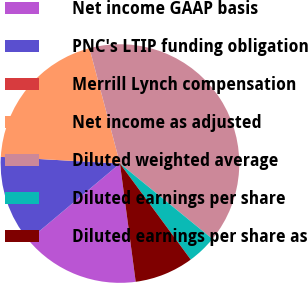Convert chart to OTSL. <chart><loc_0><loc_0><loc_500><loc_500><pie_chart><fcel>Net income GAAP basis<fcel>PNC's LTIP funding obligation<fcel>Merrill Lynch compensation<fcel>Net income as adjusted<fcel>Diluted weighted average<fcel>Diluted earnings per share<fcel>Diluted earnings per share as<nl><fcel>16.0%<fcel>12.0%<fcel>0.0%<fcel>20.0%<fcel>40.0%<fcel>4.0%<fcel>8.0%<nl></chart> 